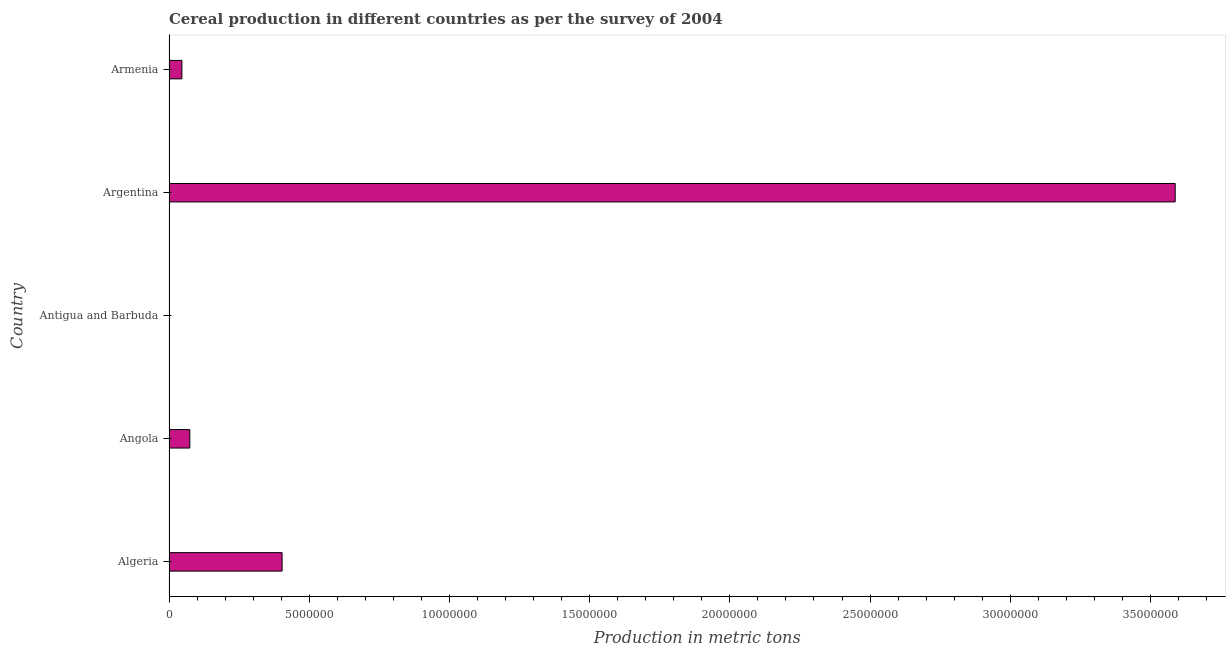What is the title of the graph?
Offer a very short reply. Cereal production in different countries as per the survey of 2004. What is the label or title of the X-axis?
Your answer should be very brief. Production in metric tons. What is the cereal production in Algeria?
Make the answer very short. 4.03e+06. Across all countries, what is the maximum cereal production?
Make the answer very short. 3.59e+07. Across all countries, what is the minimum cereal production?
Your response must be concise. 60. In which country was the cereal production minimum?
Your answer should be compact. Antigua and Barbuda. What is the sum of the cereal production?
Make the answer very short. 4.11e+07. What is the difference between the cereal production in Angola and Argentina?
Ensure brevity in your answer.  -3.51e+07. What is the average cereal production per country?
Offer a very short reply. 8.22e+06. What is the median cereal production?
Give a very brief answer. 7.42e+05. In how many countries, is the cereal production greater than 7000000 metric tons?
Give a very brief answer. 1. What is the ratio of the cereal production in Algeria to that in Angola?
Your response must be concise. 5.43. Is the difference between the cereal production in Algeria and Armenia greater than the difference between any two countries?
Your answer should be compact. No. What is the difference between the highest and the second highest cereal production?
Make the answer very short. 3.18e+07. Is the sum of the cereal production in Angola and Antigua and Barbuda greater than the maximum cereal production across all countries?
Your answer should be very brief. No. What is the difference between the highest and the lowest cereal production?
Offer a very short reply. 3.59e+07. In how many countries, is the cereal production greater than the average cereal production taken over all countries?
Offer a very short reply. 1. How many bars are there?
Offer a terse response. 5. How many countries are there in the graph?
Your response must be concise. 5. What is the difference between two consecutive major ticks on the X-axis?
Keep it short and to the point. 5.00e+06. What is the Production in metric tons of Algeria?
Your response must be concise. 4.03e+06. What is the Production in metric tons of Angola?
Your answer should be very brief. 7.42e+05. What is the Production in metric tons in Antigua and Barbuda?
Make the answer very short. 60. What is the Production in metric tons of Argentina?
Offer a terse response. 3.59e+07. What is the Production in metric tons in Armenia?
Your response must be concise. 4.60e+05. What is the difference between the Production in metric tons in Algeria and Angola?
Offer a very short reply. 3.29e+06. What is the difference between the Production in metric tons in Algeria and Antigua and Barbuda?
Offer a terse response. 4.03e+06. What is the difference between the Production in metric tons in Algeria and Argentina?
Give a very brief answer. -3.18e+07. What is the difference between the Production in metric tons in Algeria and Armenia?
Keep it short and to the point. 3.57e+06. What is the difference between the Production in metric tons in Angola and Antigua and Barbuda?
Provide a short and direct response. 7.42e+05. What is the difference between the Production in metric tons in Angola and Argentina?
Provide a succinct answer. -3.51e+07. What is the difference between the Production in metric tons in Angola and Armenia?
Give a very brief answer. 2.82e+05. What is the difference between the Production in metric tons in Antigua and Barbuda and Argentina?
Offer a terse response. -3.59e+07. What is the difference between the Production in metric tons in Antigua and Barbuda and Armenia?
Ensure brevity in your answer.  -4.60e+05. What is the difference between the Production in metric tons in Argentina and Armenia?
Your response must be concise. 3.54e+07. What is the ratio of the Production in metric tons in Algeria to that in Angola?
Your answer should be very brief. 5.43. What is the ratio of the Production in metric tons in Algeria to that in Antigua and Barbuda?
Make the answer very short. 6.72e+04. What is the ratio of the Production in metric tons in Algeria to that in Argentina?
Keep it short and to the point. 0.11. What is the ratio of the Production in metric tons in Algeria to that in Armenia?
Your answer should be very brief. 8.77. What is the ratio of the Production in metric tons in Angola to that in Antigua and Barbuda?
Your response must be concise. 1.24e+04. What is the ratio of the Production in metric tons in Angola to that in Argentina?
Provide a short and direct response. 0.02. What is the ratio of the Production in metric tons in Angola to that in Armenia?
Keep it short and to the point. 1.61. What is the ratio of the Production in metric tons in Argentina to that in Armenia?
Your response must be concise. 78.01. 